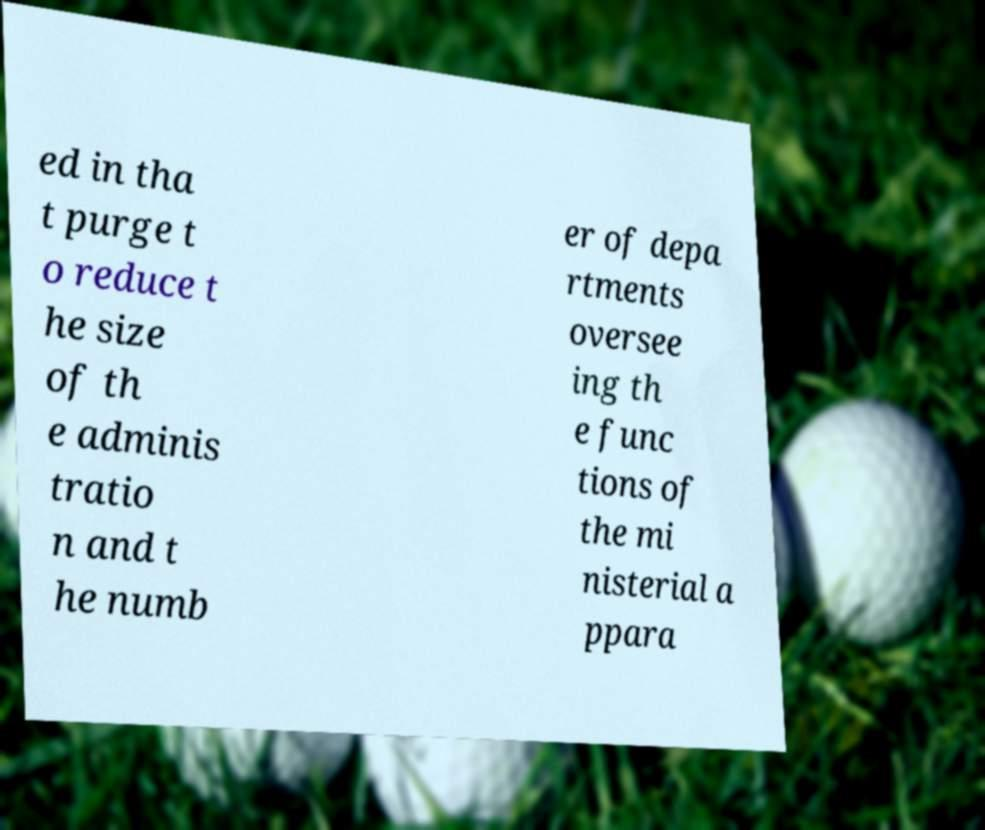Can you read and provide the text displayed in the image?This photo seems to have some interesting text. Can you extract and type it out for me? ed in tha t purge t o reduce t he size of th e adminis tratio n and t he numb er of depa rtments oversee ing th e func tions of the mi nisterial a ppara 